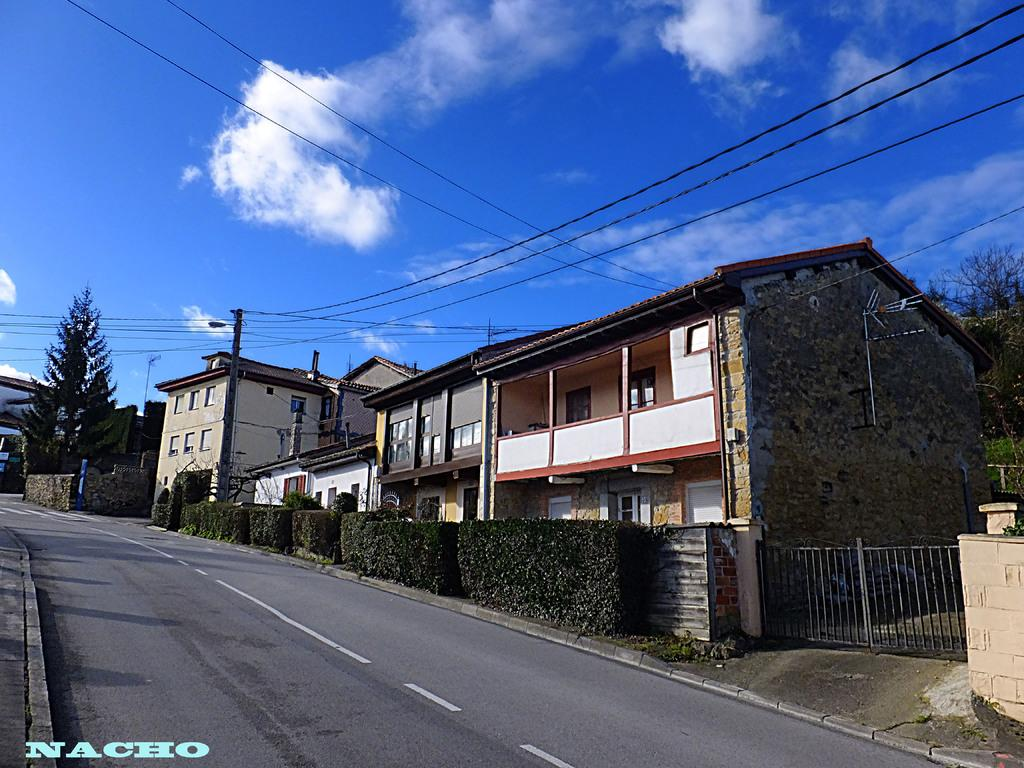<image>
Render a clear and concise summary of the photo. A street and some houses on a sunny day by nacho. 